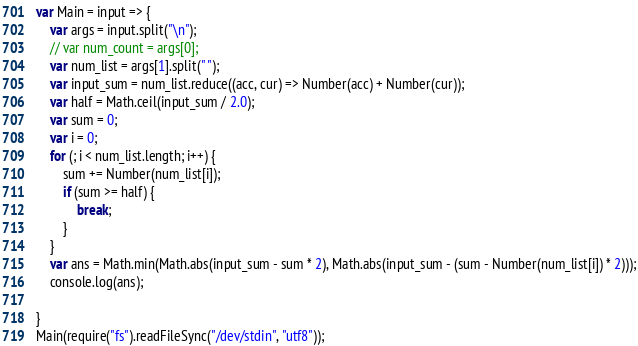<code> <loc_0><loc_0><loc_500><loc_500><_JavaScript_>var Main = input => {
    var args = input.split("\n");
    // var num_count = args[0];
    var num_list = args[1].split(" ");
    var input_sum = num_list.reduce((acc, cur) => Number(acc) + Number(cur));
    var half = Math.ceil(input_sum / 2.0);
    var sum = 0;
    var i = 0;
    for (; i < num_list.length; i++) {
        sum += Number(num_list[i]);
        if (sum >= half) {
            break;
        }
    }
    var ans = Math.min(Math.abs(input_sum - sum * 2), Math.abs(input_sum - (sum - Number(num_list[i]) * 2)));
    console.log(ans);

}
Main(require("fs").readFileSync("/dev/stdin", "utf8"));</code> 